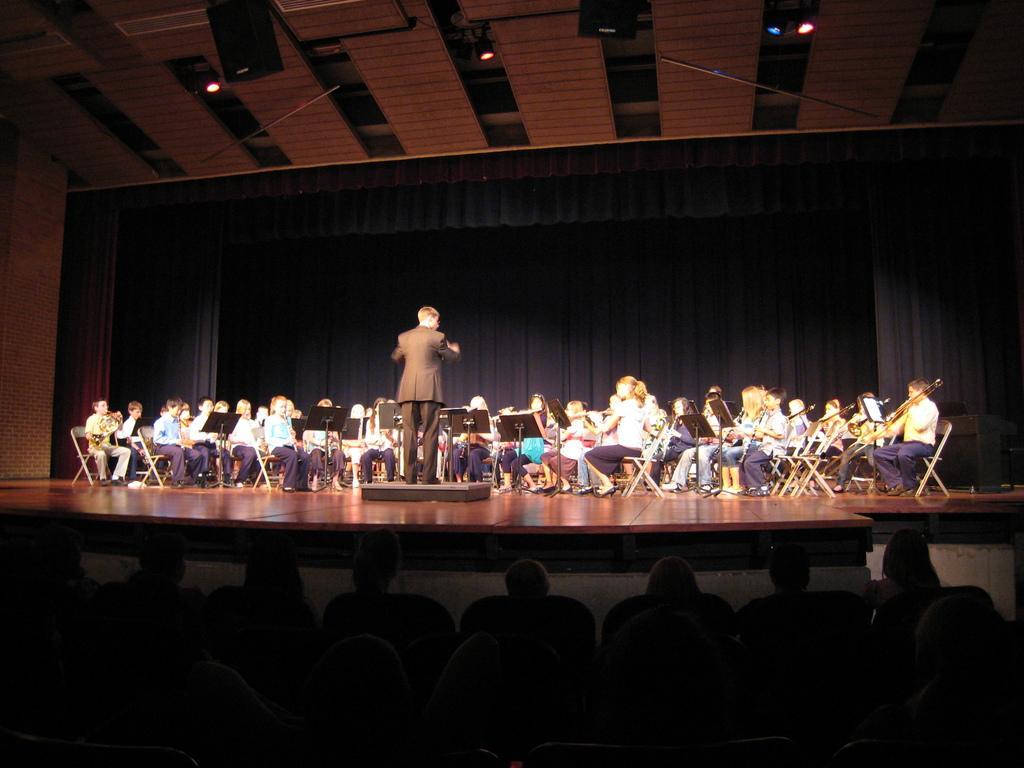In one or two sentences, can you explain what this image depicts? In this image in the middle, there is a man, he wears a suit, trouser, he is standing. On the right there is a man, he wears a shirt, trouser, shoes, he is sitting, he is playing the violin. On the left there is a boy, he wears a shirt, trouser, shoes, he is sitting, he is playing the violin. In the middle there are many people, they are playing violin, they are on the stage. At the bottom there are some people. 